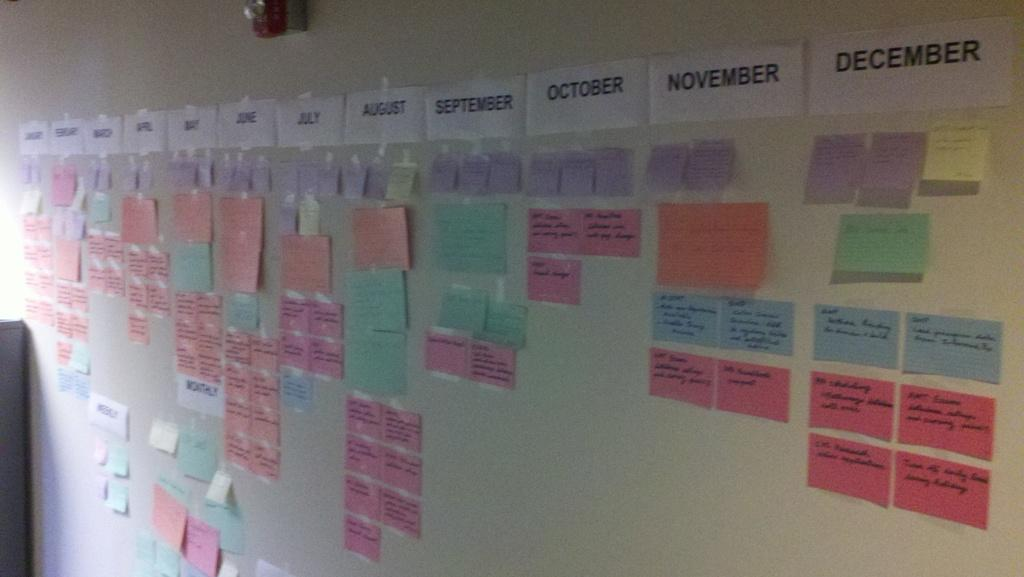<image>
Describe the image concisely. Board with many post notes and the month of December at the top right. 